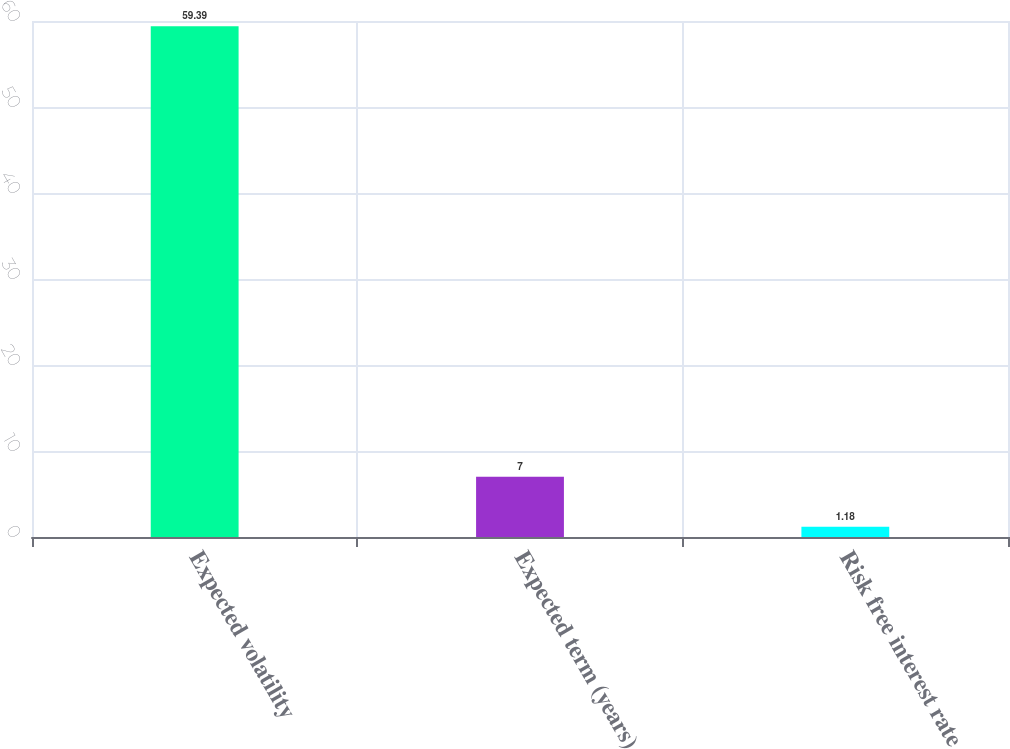Convert chart to OTSL. <chart><loc_0><loc_0><loc_500><loc_500><bar_chart><fcel>Expected volatility<fcel>Expected term (years)<fcel>Risk free interest rate<nl><fcel>59.39<fcel>7<fcel>1.18<nl></chart> 